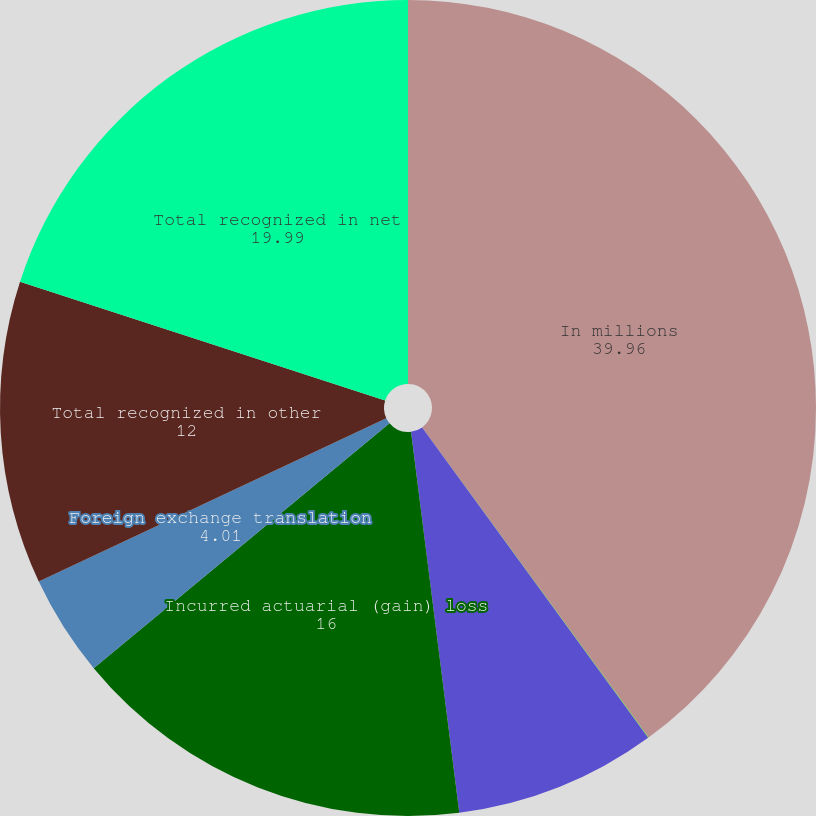<chart> <loc_0><loc_0><loc_500><loc_500><pie_chart><fcel>In millions<fcel>Amortization of prior service<fcel>Recognized actuarial loss<fcel>Incurred actuarial (gain) loss<fcel>Foreign exchange translation<fcel>Total recognized in other<fcel>Total recognized in net<nl><fcel>39.96%<fcel>0.02%<fcel>8.01%<fcel>16.0%<fcel>4.01%<fcel>12.0%<fcel>19.99%<nl></chart> 